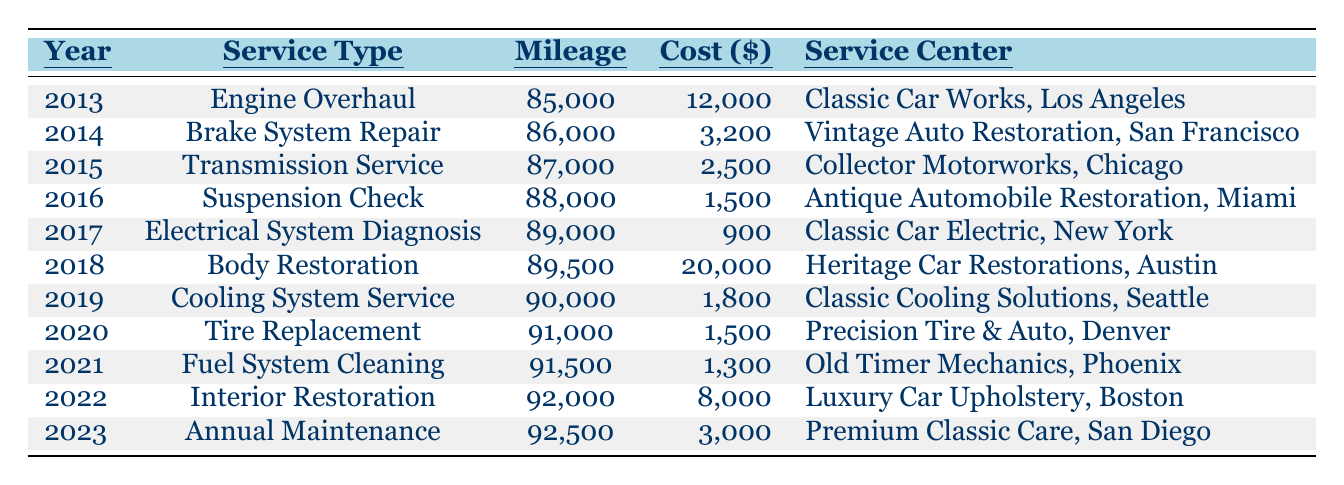What was the cost of the Body Restoration service in 2018? The table shows the entry for 2018 under the Service Type "Body Restoration," which has a corresponding cost of $20,000.
Answer: $20,000 How many miles were on the car during the Annual Maintenance in 2023? The table indicates that in the year 2023, the Mileage for the Annual Maintenance service is 92,500 miles.
Answer: 92,500 miles What is the total cost of all maintenance services from 2013 to 2023? To find the total cost, sum the costs of each service: 12,000 + 3,200 + 2,500 + 1,500 + 900 + 20,000 + 1,800 + 1,500 + 1,300 + 8,000 + 3,000 = 54,700.
Answer: $54,700 Which service had the highest cost? The service with the highest cost, as indicated in the provided table, is the Body Restoration service in 2018 with a cost of $20,000.
Answer: $20,000 Was there any service done in the year 2020? Yes, the table lists a Tire Replacement service conducted in 2020.
Answer: Yes What is the average cost of maintenance services per year over this decade? Add the costs: 12,000 + 3,200 + 2,500 + 1,500 + 900 + 20,000 + 1,800 + 1,500 + 1,300 + 8,000 + 3,000 = 54,700. Since there are 11 years, divide by 11: 54,700 / 11 = 4,972.73.
Answer: $4,972.73 In which year was the Electrical System Diagnosis service performed? The Electrical System Diagnosis service was performed in the year 2017, as listed in that row of the table.
Answer: 2017 How many miles did the car have after the Transmission Service in 2015? The Mileage after the Transmission Service in 2015 was reported as 87,000 in the corresponding row of the table.
Answer: 87,000 miles Which maintenance service cost less than $2,000? According to the table, the only service that cost less than $2,000 is the Electrical System Diagnosis in 2017, which was $900.
Answer: Yes What was the yearly increase in mileage from 2013 to 2023? The increase in mileage from 85,000 in 2013 to 92,500 in 2023 is calculated by subtracting: 92,500 - 85,000 = 7,500. To find the average yearly increase: 7,500 / 10 = 750.
Answer: 750 miles/year 